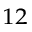<formula> <loc_0><loc_0><loc_500><loc_500>^ { 1 2 }</formula> 